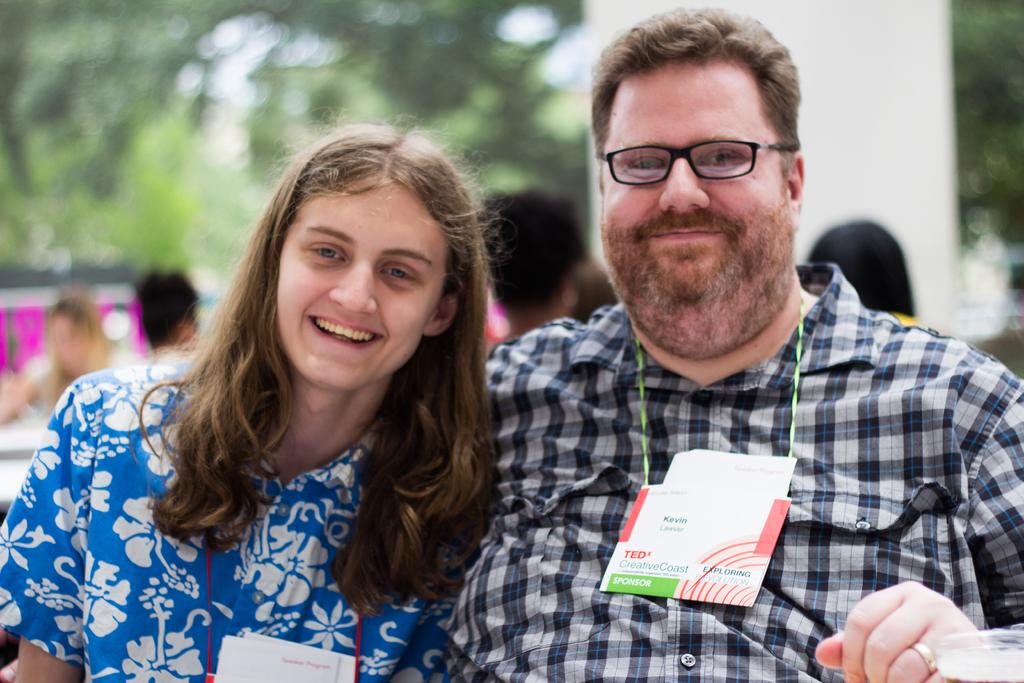Who can be seen in the foreground of the image? There is a man and a woman in the foreground of the image. What are the man and the woman wearing? Both the man and the woman are wearing ID tags. Can you describe the background of the image? The background of the image includes blurred persons and trees. What type of cow can be seen drinking from the sink in the image? There is no cow or sink present in the image. What kind of paper is visible on the table in the image? There is no table or paper visible in the image. 